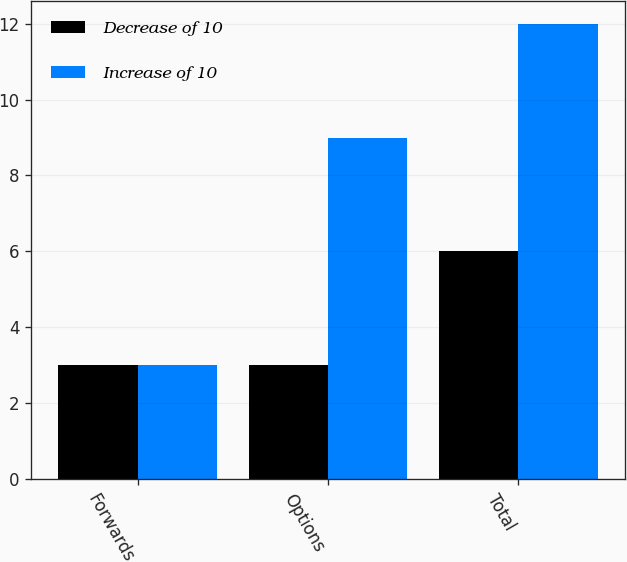<chart> <loc_0><loc_0><loc_500><loc_500><stacked_bar_chart><ecel><fcel>Forwards<fcel>Options<fcel>Total<nl><fcel>Decrease of 10<fcel>3<fcel>3<fcel>6<nl><fcel>Increase of 10<fcel>3<fcel>9<fcel>12<nl></chart> 